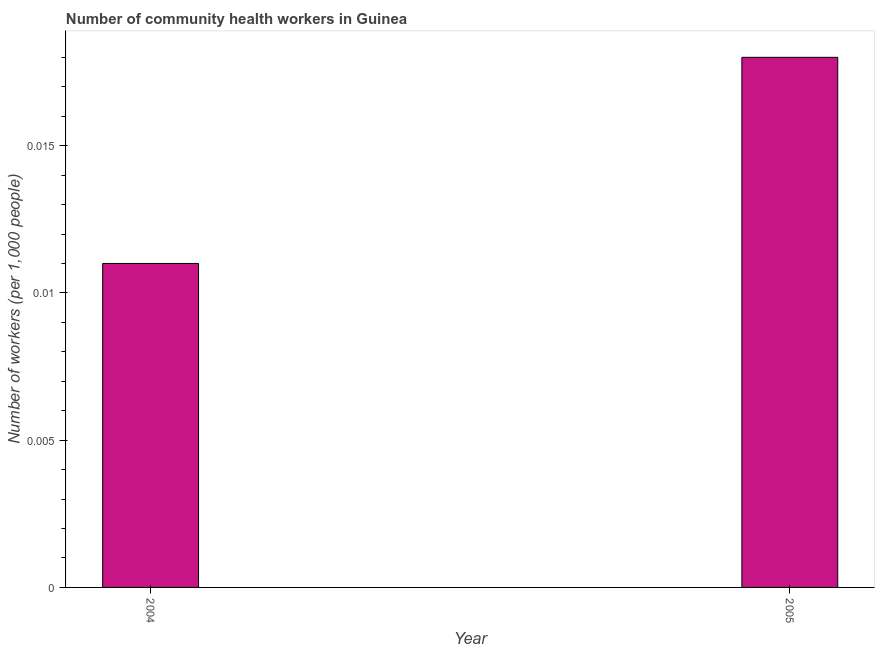What is the title of the graph?
Offer a very short reply. Number of community health workers in Guinea. What is the label or title of the X-axis?
Your answer should be compact. Year. What is the label or title of the Y-axis?
Provide a succinct answer. Number of workers (per 1,0 people). What is the number of community health workers in 2005?
Your answer should be compact. 0.02. Across all years, what is the maximum number of community health workers?
Keep it short and to the point. 0.02. Across all years, what is the minimum number of community health workers?
Offer a terse response. 0.01. In which year was the number of community health workers minimum?
Provide a short and direct response. 2004. What is the sum of the number of community health workers?
Provide a short and direct response. 0.03. What is the difference between the number of community health workers in 2004 and 2005?
Give a very brief answer. -0.01. What is the average number of community health workers per year?
Your answer should be very brief. 0.01. What is the median number of community health workers?
Give a very brief answer. 0.01. Do a majority of the years between 2004 and 2005 (inclusive) have number of community health workers greater than 0.009 ?
Offer a terse response. Yes. What is the ratio of the number of community health workers in 2004 to that in 2005?
Ensure brevity in your answer.  0.61. Is the number of community health workers in 2004 less than that in 2005?
Provide a succinct answer. Yes. How many bars are there?
Keep it short and to the point. 2. What is the difference between two consecutive major ticks on the Y-axis?
Your response must be concise. 0.01. What is the Number of workers (per 1,000 people) in 2004?
Your answer should be compact. 0.01. What is the Number of workers (per 1,000 people) in 2005?
Offer a very short reply. 0.02. What is the difference between the Number of workers (per 1,000 people) in 2004 and 2005?
Keep it short and to the point. -0.01. What is the ratio of the Number of workers (per 1,000 people) in 2004 to that in 2005?
Make the answer very short. 0.61. 